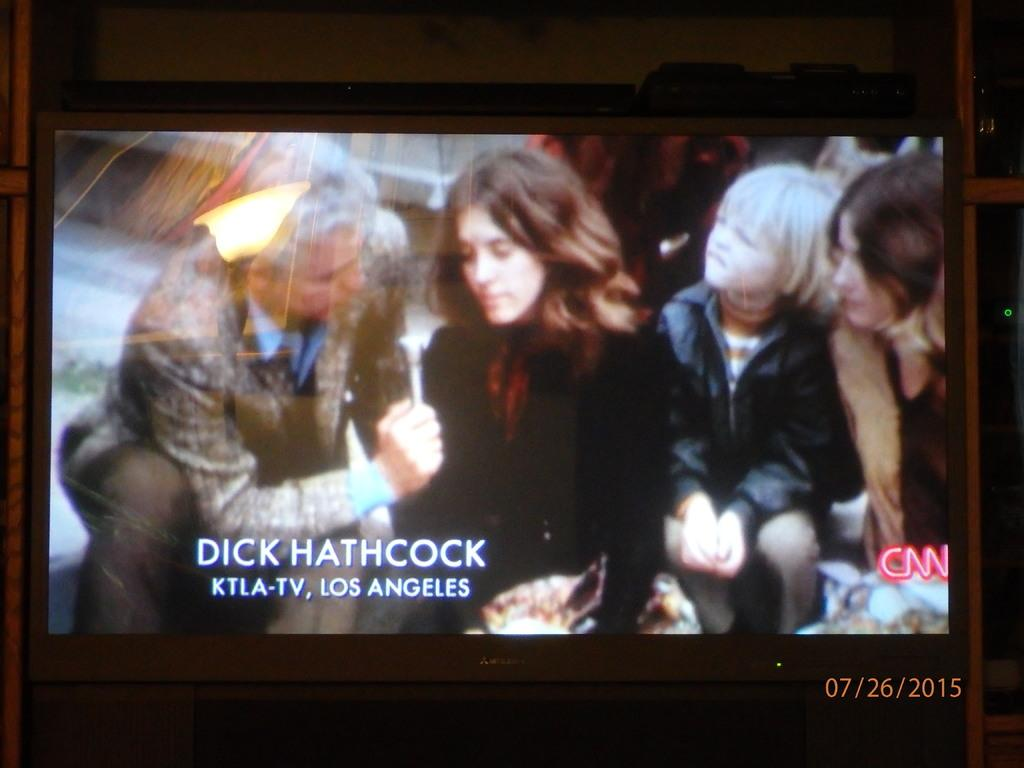Provide a one-sentence caption for the provided image. A picture of a TV interview with the name Dick Hathcock at the bottom left. 